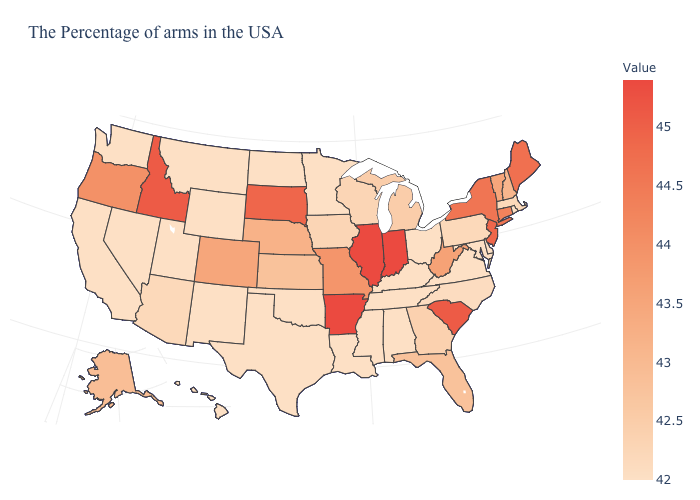Which states hav the highest value in the West?
Quick response, please. Idaho. Does Georgia have the lowest value in the South?
Concise answer only. No. Among the states that border South Carolina , does Georgia have the lowest value?
Answer briefly. No. Is the legend a continuous bar?
Short answer required. Yes. 